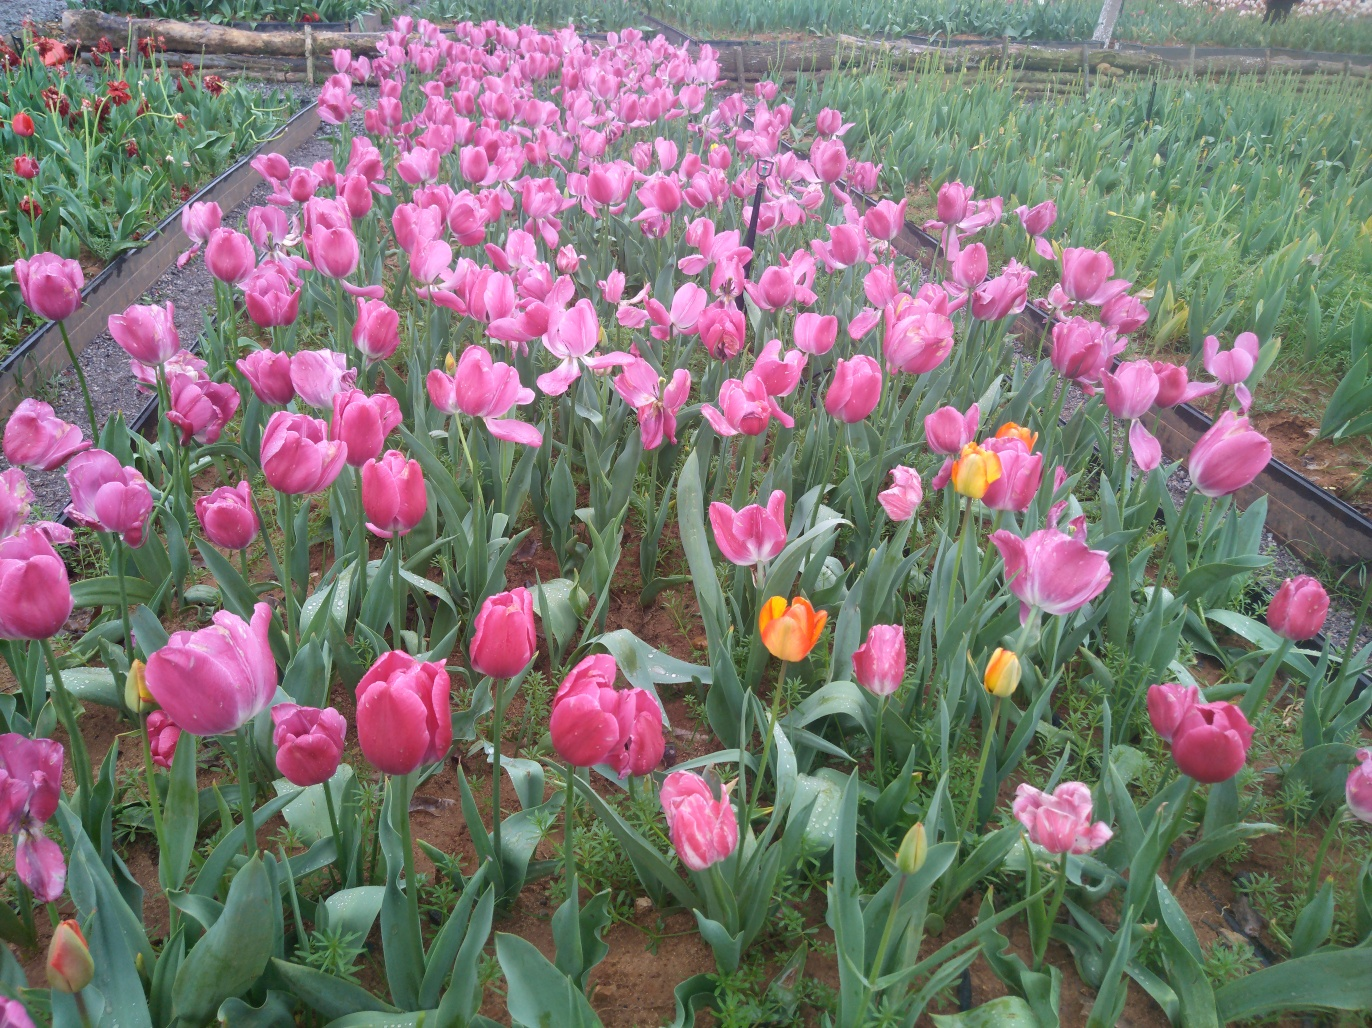Could these tulips be part of a larger ecological habitat? Yes, while these tulips are cultivated, they're still an integral part of the local ecosystem. They can provide nectar for pollinators like bees and butterflies. Also, tulips can contribute to soil health by preventing erosion and possibly creating a microhabitat for other flora and fauna in the surrounding area. However, the true impact on the larger ecosystem would depend on factors such as the use of pesticides and integration with native plant species. 